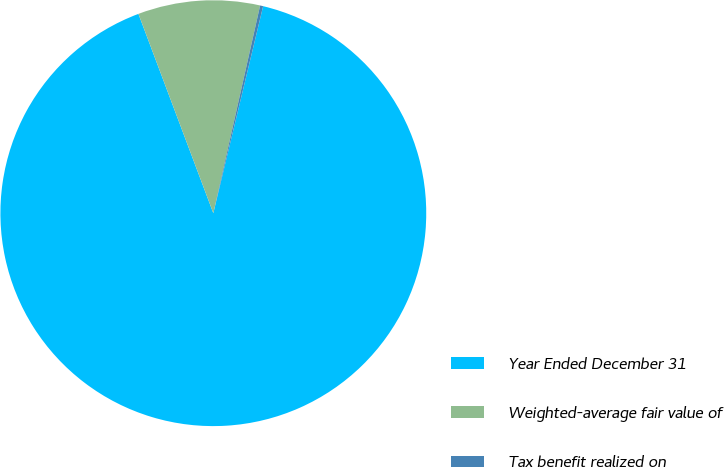Convert chart to OTSL. <chart><loc_0><loc_0><loc_500><loc_500><pie_chart><fcel>Year Ended December 31<fcel>Weighted-average fair value of<fcel>Tax benefit realized on<nl><fcel>90.52%<fcel>9.25%<fcel>0.23%<nl></chart> 